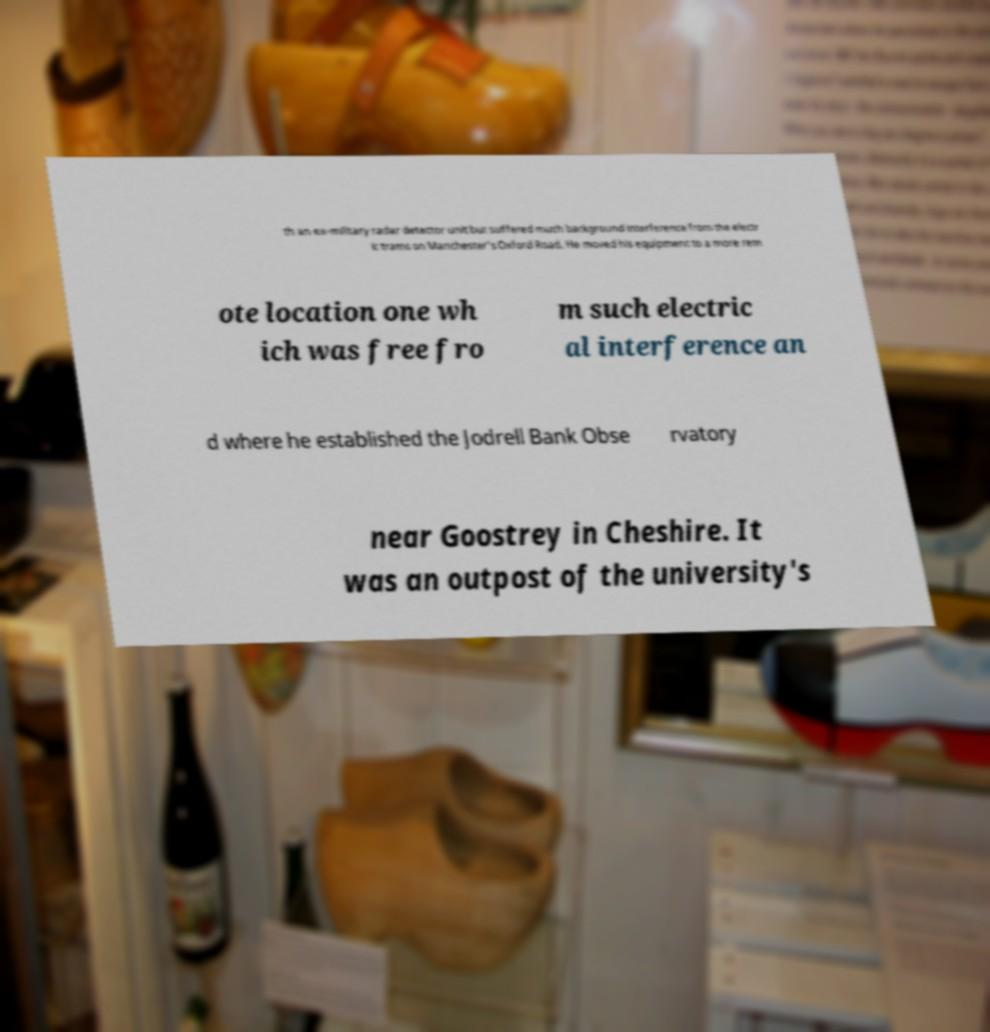I need the written content from this picture converted into text. Can you do that? th an ex-military radar detector unit but suffered much background interference from the electr ic trams on Manchester's Oxford Road. He moved his equipment to a more rem ote location one wh ich was free fro m such electric al interference an d where he established the Jodrell Bank Obse rvatory near Goostrey in Cheshire. It was an outpost of the university's 